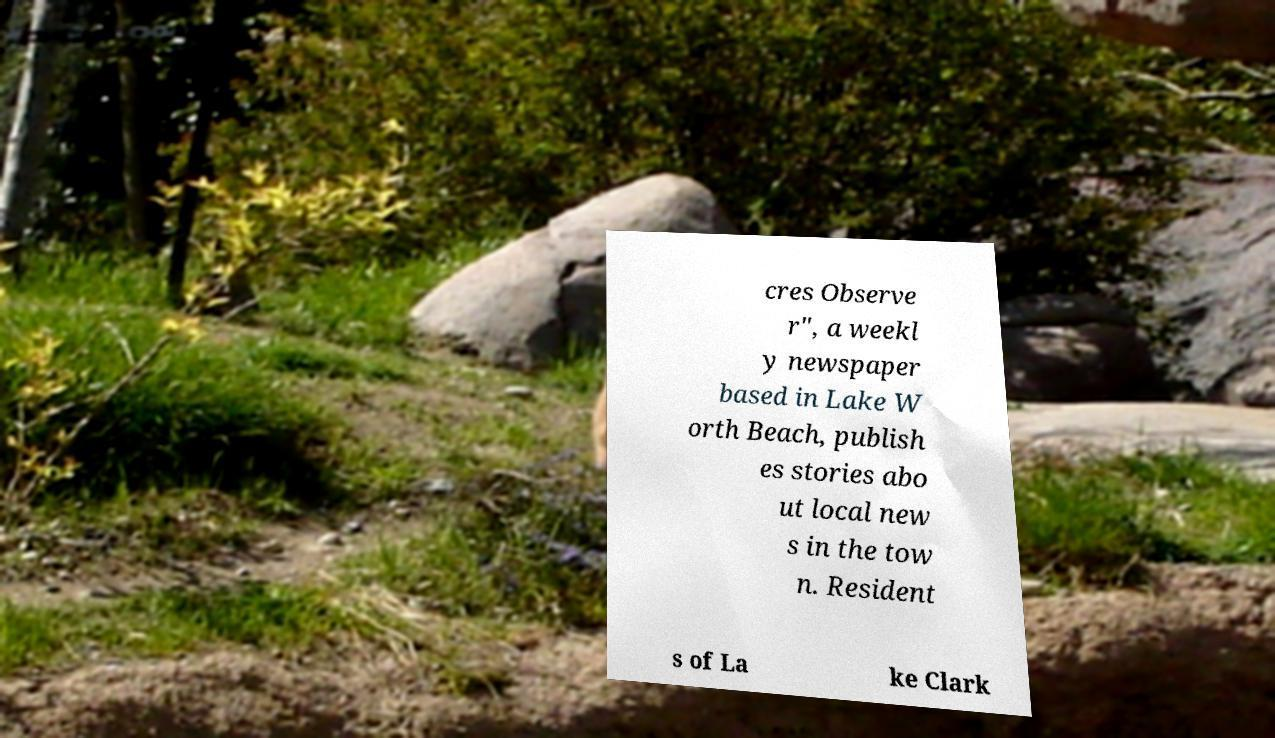Can you accurately transcribe the text from the provided image for me? cres Observe r", a weekl y newspaper based in Lake W orth Beach, publish es stories abo ut local new s in the tow n. Resident s of La ke Clark 